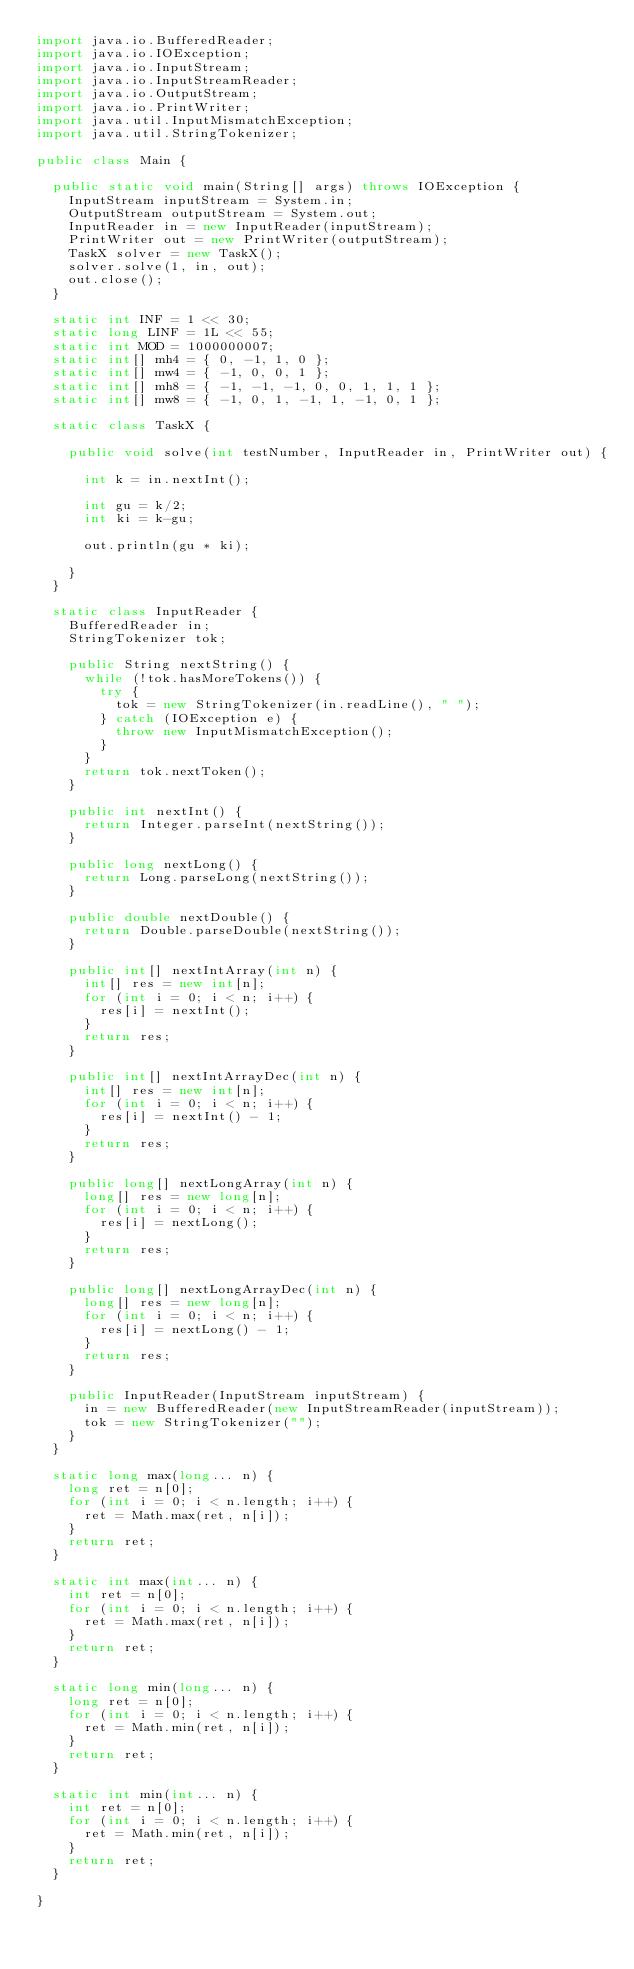<code> <loc_0><loc_0><loc_500><loc_500><_Java_>import java.io.BufferedReader;
import java.io.IOException;
import java.io.InputStream;
import java.io.InputStreamReader;
import java.io.OutputStream;
import java.io.PrintWriter;
import java.util.InputMismatchException;
import java.util.StringTokenizer;

public class Main {

	public static void main(String[] args) throws IOException {
		InputStream inputStream = System.in;
		OutputStream outputStream = System.out;
		InputReader in = new InputReader(inputStream);
		PrintWriter out = new PrintWriter(outputStream);
		TaskX solver = new TaskX();
		solver.solve(1, in, out);
		out.close();
	}

	static int INF = 1 << 30;
	static long LINF = 1L << 55;
	static int MOD = 1000000007;
	static int[] mh4 = { 0, -1, 1, 0 };
	static int[] mw4 = { -1, 0, 0, 1 };
	static int[] mh8 = { -1, -1, -1, 0, 0, 1, 1, 1 };
	static int[] mw8 = { -1, 0, 1, -1, 1, -1, 0, 1 };

	static class TaskX {

		public void solve(int testNumber, InputReader in, PrintWriter out) {

			int k = in.nextInt();

			int gu = k/2;
			int ki = k-gu;

			out.println(gu * ki);

		}
	}

	static class InputReader {
		BufferedReader in;
		StringTokenizer tok;

		public String nextString() {
			while (!tok.hasMoreTokens()) {
				try {
					tok = new StringTokenizer(in.readLine(), " ");
				} catch (IOException e) {
					throw new InputMismatchException();
				}
			}
			return tok.nextToken();
		}

		public int nextInt() {
			return Integer.parseInt(nextString());
		}

		public long nextLong() {
			return Long.parseLong(nextString());
		}

		public double nextDouble() {
			return Double.parseDouble(nextString());
		}

		public int[] nextIntArray(int n) {
			int[] res = new int[n];
			for (int i = 0; i < n; i++) {
				res[i] = nextInt();
			}
			return res;
		}

		public int[] nextIntArrayDec(int n) {
			int[] res = new int[n];
			for (int i = 0; i < n; i++) {
				res[i] = nextInt() - 1;
			}
			return res;
		}

		public long[] nextLongArray(int n) {
			long[] res = new long[n];
			for (int i = 0; i < n; i++) {
				res[i] = nextLong();
			}
			return res;
		}

		public long[] nextLongArrayDec(int n) {
			long[] res = new long[n];
			for (int i = 0; i < n; i++) {
				res[i] = nextLong() - 1;
			}
			return res;
		}

		public InputReader(InputStream inputStream) {
			in = new BufferedReader(new InputStreamReader(inputStream));
			tok = new StringTokenizer("");
		}
	}

	static long max(long... n) {
		long ret = n[0];
		for (int i = 0; i < n.length; i++) {
			ret = Math.max(ret, n[i]);
		}
		return ret;
	}

	static int max(int... n) {
		int ret = n[0];
		for (int i = 0; i < n.length; i++) {
			ret = Math.max(ret, n[i]);
		}
		return ret;
	}

	static long min(long... n) {
		long ret = n[0];
		for (int i = 0; i < n.length; i++) {
			ret = Math.min(ret, n[i]);
		}
		return ret;
	}

	static int min(int... n) {
		int ret = n[0];
		for (int i = 0; i < n.length; i++) {
			ret = Math.min(ret, n[i]);
		}
		return ret;
	}

}
</code> 